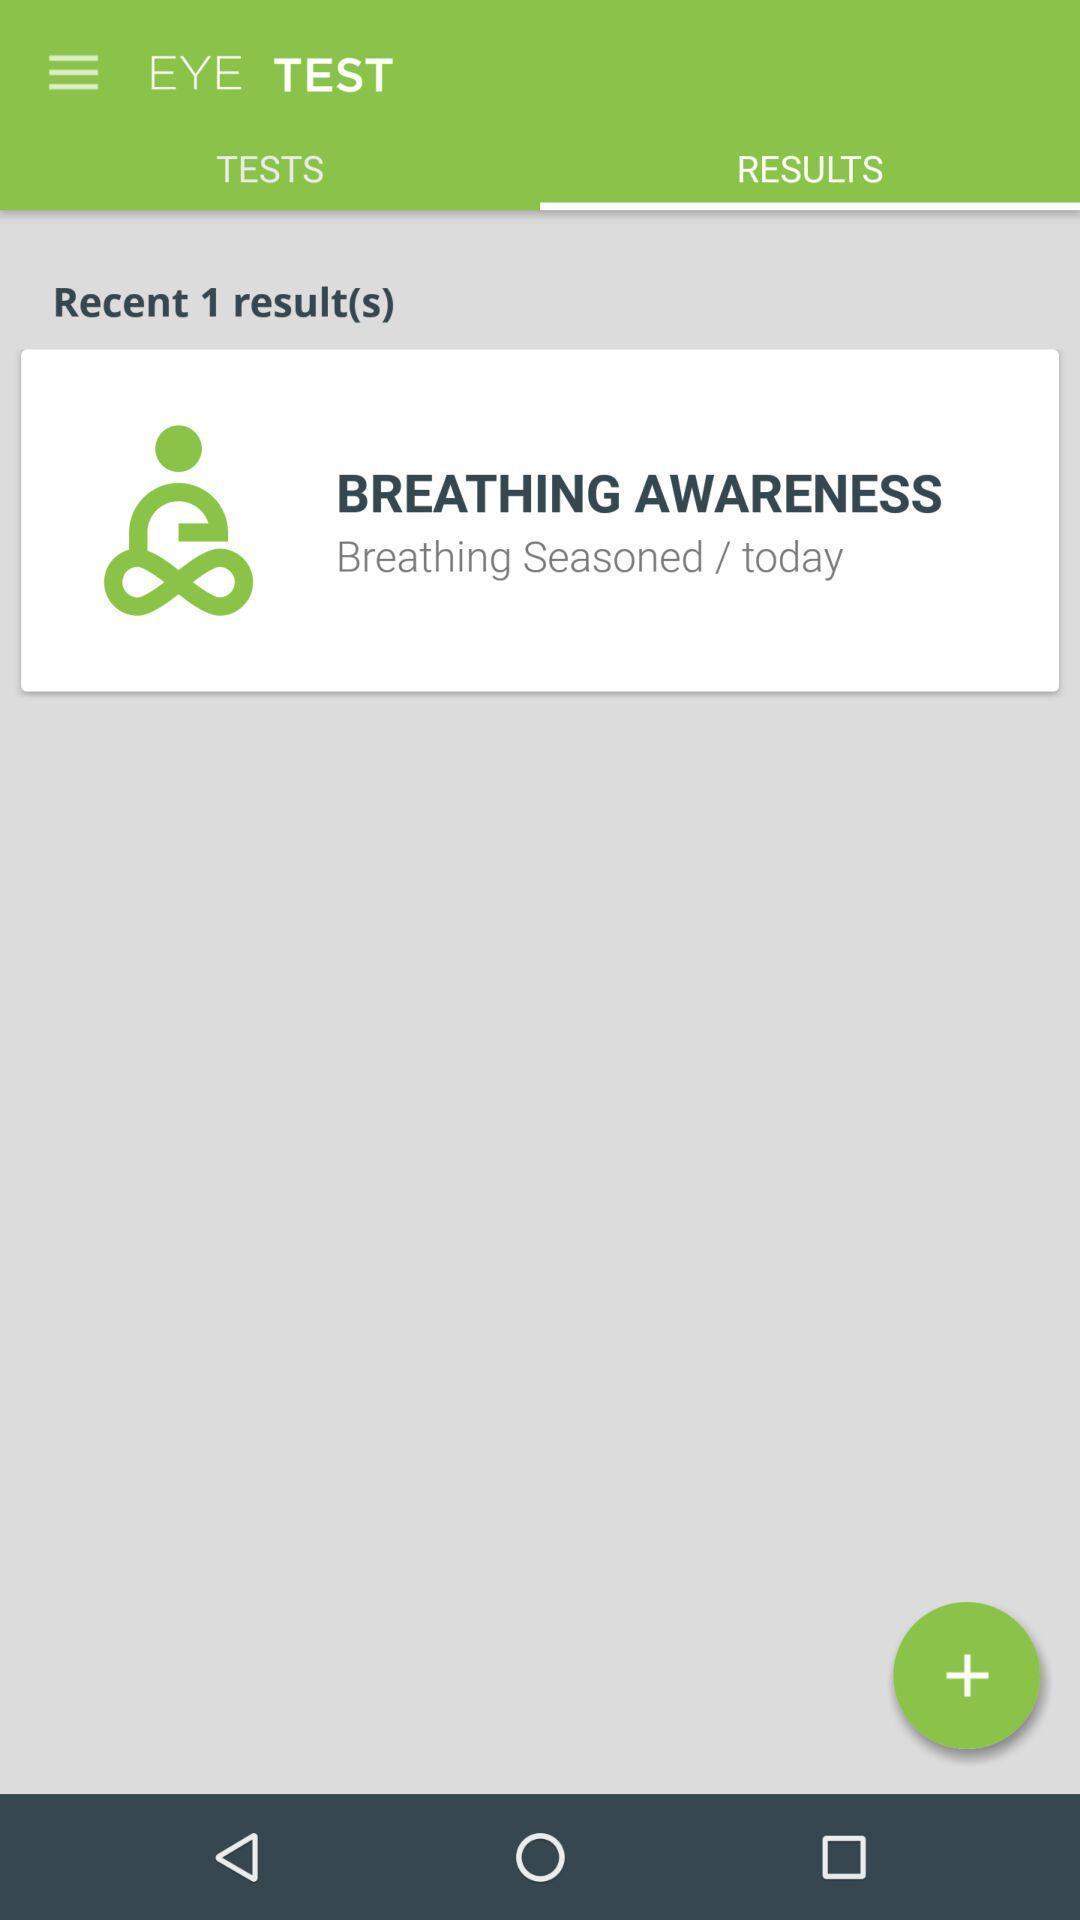Provide a textual representation of this image. Window displaying a page for eye test. 